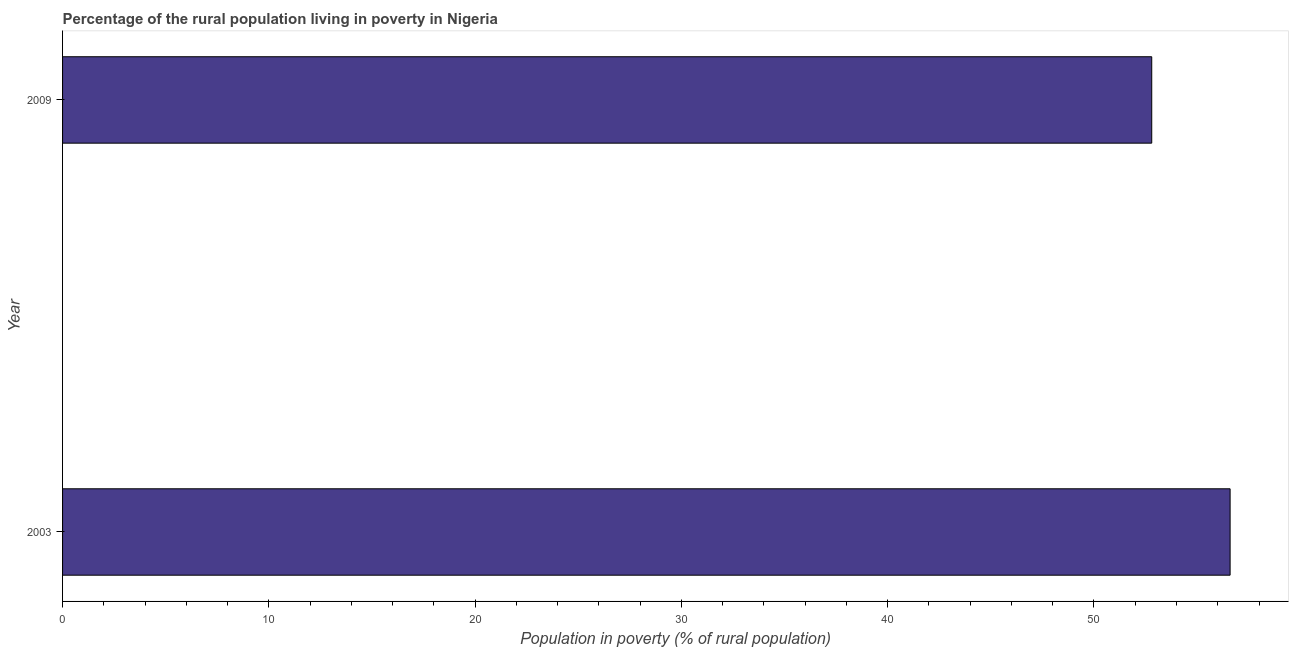Does the graph contain grids?
Offer a terse response. No. What is the title of the graph?
Keep it short and to the point. Percentage of the rural population living in poverty in Nigeria. What is the label or title of the X-axis?
Make the answer very short. Population in poverty (% of rural population). What is the label or title of the Y-axis?
Your response must be concise. Year. What is the percentage of rural population living below poverty line in 2003?
Keep it short and to the point. 56.6. Across all years, what is the maximum percentage of rural population living below poverty line?
Ensure brevity in your answer.  56.6. Across all years, what is the minimum percentage of rural population living below poverty line?
Give a very brief answer. 52.8. In which year was the percentage of rural population living below poverty line minimum?
Provide a short and direct response. 2009. What is the sum of the percentage of rural population living below poverty line?
Offer a very short reply. 109.4. What is the difference between the percentage of rural population living below poverty line in 2003 and 2009?
Offer a very short reply. 3.8. What is the average percentage of rural population living below poverty line per year?
Offer a terse response. 54.7. What is the median percentage of rural population living below poverty line?
Your answer should be very brief. 54.7. What is the ratio of the percentage of rural population living below poverty line in 2003 to that in 2009?
Provide a succinct answer. 1.07. How many bars are there?
Provide a short and direct response. 2. How many years are there in the graph?
Offer a terse response. 2. What is the Population in poverty (% of rural population) in 2003?
Provide a succinct answer. 56.6. What is the Population in poverty (% of rural population) of 2009?
Make the answer very short. 52.8. What is the ratio of the Population in poverty (% of rural population) in 2003 to that in 2009?
Offer a terse response. 1.07. 